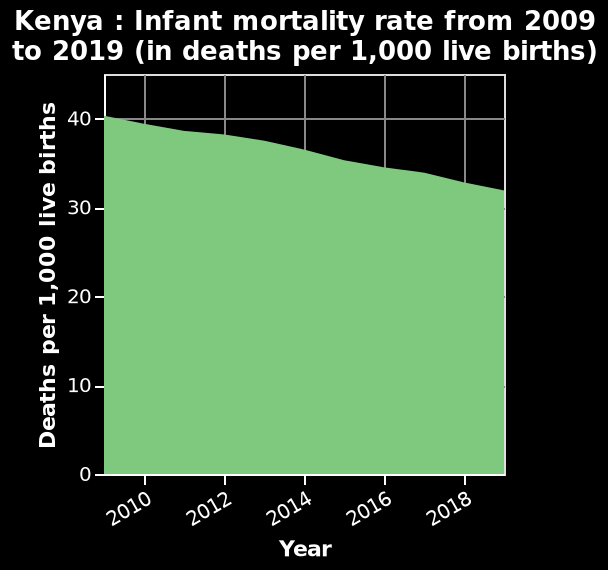<image>
When did the rate of decline in infant mortality increase in Kenya?  The rate of decline in infant mortality increased in the later part of the period from 2009 to 2019. What is being represented by the x-axis on the graph? The x-axis on the graph represents the years from 2009 to 2019. What can be inferred about the infant mortality rate if the graph reaches the maximum value on the y-axis? If the graph reaches the maximum value of 40 on the y-axis, it indicates a high infant mortality rate in Kenya. Offer a thorough analysis of the image. Infant mortality has declined in Kenya throughout the period 2009 to 2019. The rate of decline has increased in the later part of the period. Is the scale on the y-axis linear or logarithmic? The scale on the y-axis is linear, as it ranges from a minimum of 0 to a maximum of 40 with equal intervals. 